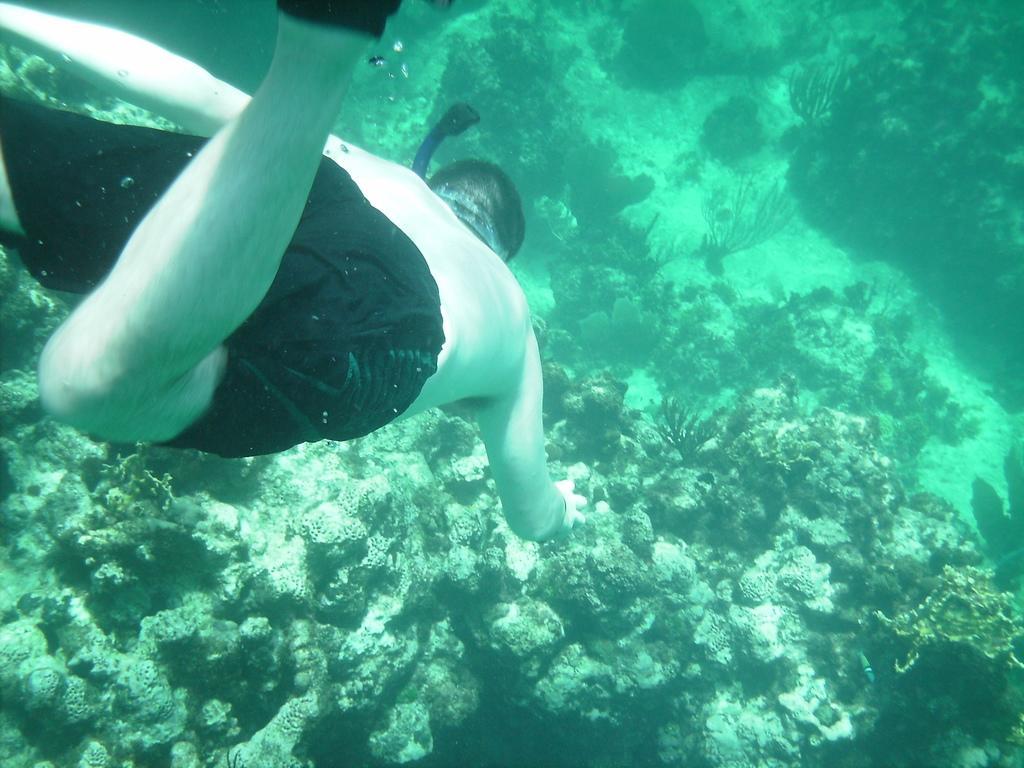What is present in the image? There is a person in the image. Can you describe the environment in the image? There is grass in the water in the image. How does the person in the image increase their skateboarding skills? The image does not show the person skateboarding or provide any information about their skills or how they might improve them. 